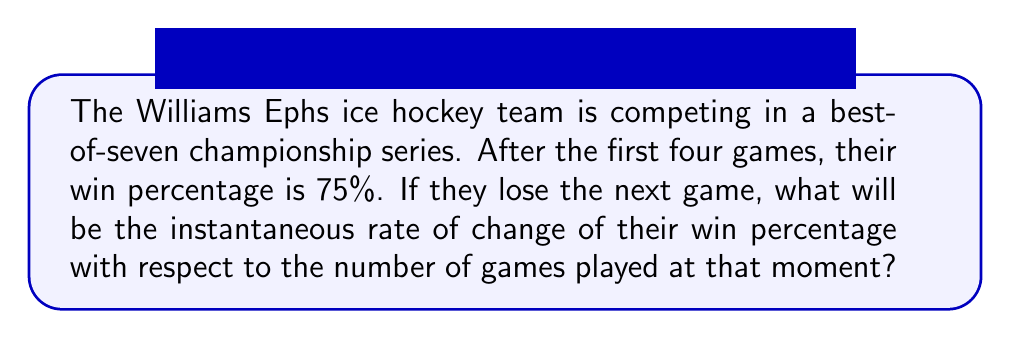Can you answer this question? Let's approach this step-by-step:

1) First, we need to define a function for the win percentage. Let $w(n)$ be the win percentage after $n$ games, where $n$ is the number of games played.

2) We know that after 4 games, the win percentage is 75%. This means they've won 3 out of 4 games.

3) If they lose the next game, they will have won 3 out of 5 games. Let's calculate the new win percentage:

   $w(5) = \frac{3}{5} = 60\%$

4) To find the instantaneous rate of change, we need to calculate the derivative of $w(n)$ at $n=5$.

5) We can approximate this using the difference quotient:

   $$\frac{dw}{dn} \approx \frac{w(5) - w(4)}{5 - 4} = \frac{60\% - 75\%}{1} = -15\%$$

6) This means that at the moment they lose the 5th game, their win percentage is decreasing at a rate of 15% per game.

7) To get the exact instantaneous rate of change, we would need to take the limit as the change in $n$ approaches 0:

   $$\frac{dw}{dn} = \lim_{h \to 0} \frac{w(5+h) - w(5)}{h}$$

8) However, in this discrete scenario where games are whole units, the difference quotient gives us the best approximation of the instantaneous rate of change.
Answer: $-15\%$ per game 